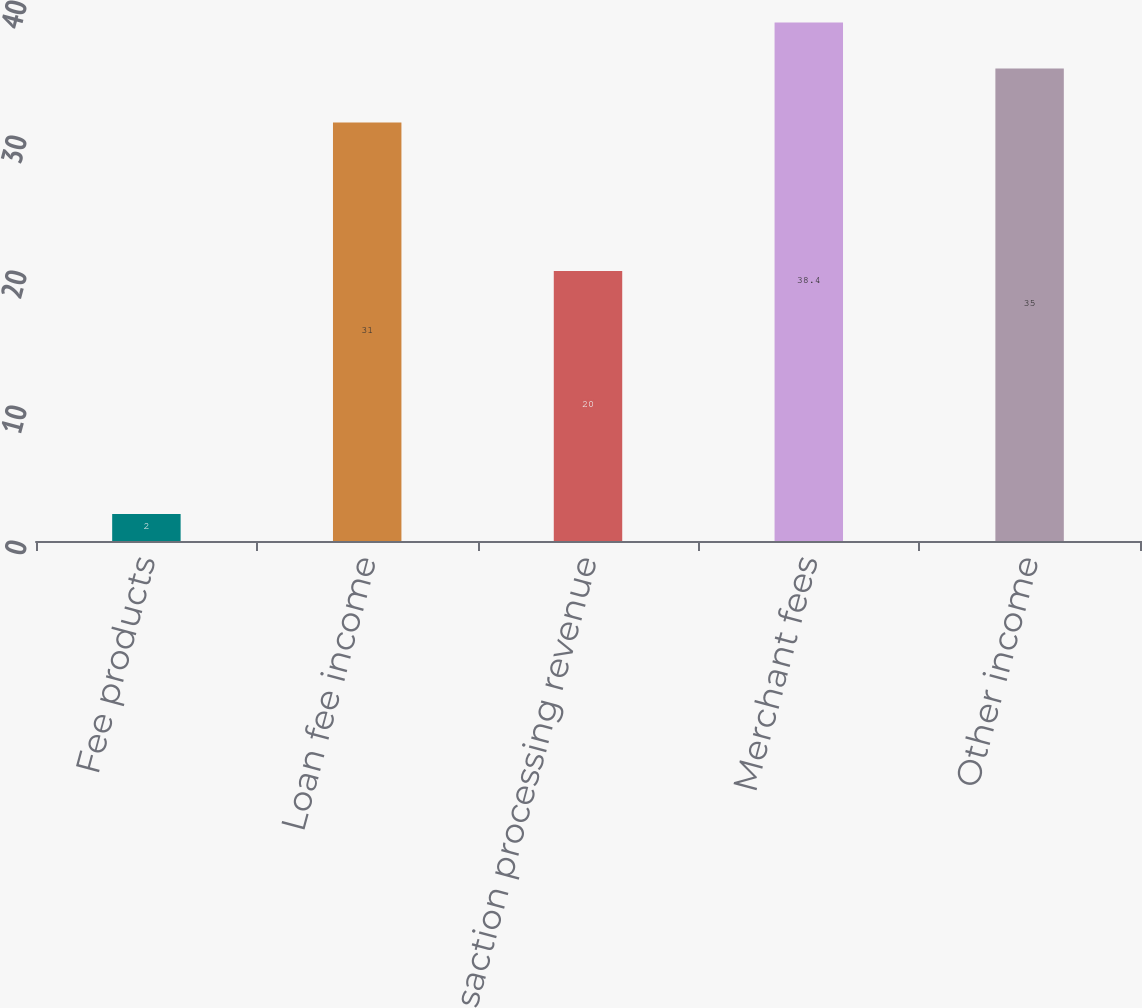Convert chart. <chart><loc_0><loc_0><loc_500><loc_500><bar_chart><fcel>Fee products<fcel>Loan fee income<fcel>Transaction processing revenue<fcel>Merchant fees<fcel>Other income<nl><fcel>2<fcel>31<fcel>20<fcel>38.4<fcel>35<nl></chart> 